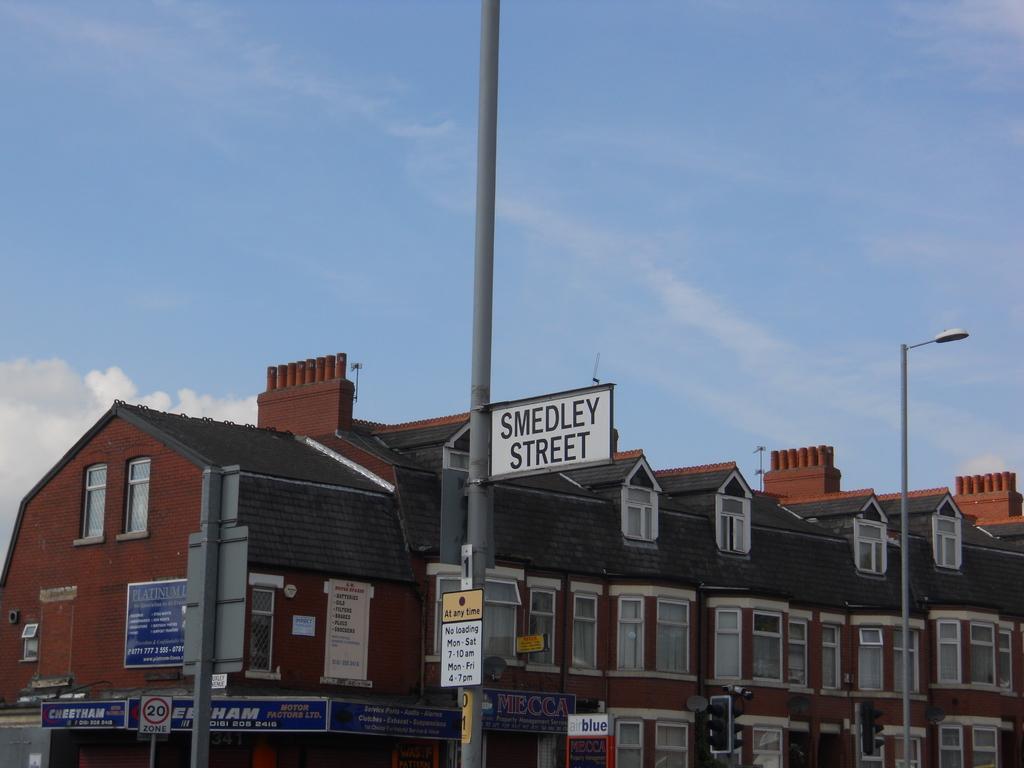In one or two sentences, can you explain what this image depicts? We can see boards and lights on poles and we can see traffic signals. In the background we can see building,windows and sky with clouds. 